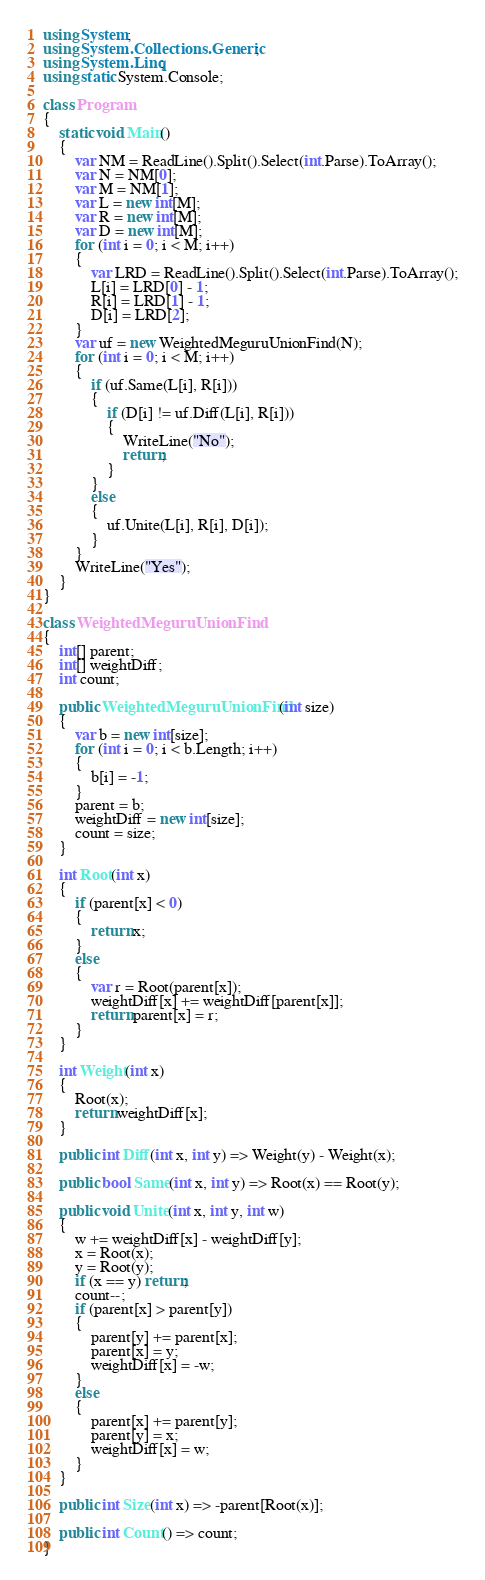<code> <loc_0><loc_0><loc_500><loc_500><_C#_>using System;
using System.Collections.Generic;
using System.Linq;
using static System.Console;

class Program
{
    static void Main()
    {
        var NM = ReadLine().Split().Select(int.Parse).ToArray();
        var N = NM[0];
        var M = NM[1];
        var L = new int[M];
        var R = new int[M];
        var D = new int[M];
        for (int i = 0; i < M; i++)
        {
            var LRD = ReadLine().Split().Select(int.Parse).ToArray();
            L[i] = LRD[0] - 1;
            R[i] = LRD[1] - 1;
            D[i] = LRD[2];
        }
        var uf = new WeightedMeguruUnionFind(N);
        for (int i = 0; i < M; i++)
        {
            if (uf.Same(L[i], R[i]))
            {
                if (D[i] != uf.Diff(L[i], R[i]))
                {
                    WriteLine("No");
                    return;
                }
            }
            else
            {
                uf.Unite(L[i], R[i], D[i]);
            }
        }
        WriteLine("Yes");
    }
}

class WeightedMeguruUnionFind
{
    int[] parent;
    int[] weightDiff;
    int count;

    public WeightedMeguruUnionFind(int size)
    {
        var b = new int[size];
        for (int i = 0; i < b.Length; i++)
        {
            b[i] = -1;
        }
        parent = b;
        weightDiff = new int[size];
        count = size;
    }

    int Root(int x)
    {
        if (parent[x] < 0)
        {
            return x;
        }
        else
        {
            var r = Root(parent[x]);
            weightDiff[x] += weightDiff[parent[x]];
            return parent[x] = r;
        }
    }

    int Weight(int x)
    {
        Root(x);
        return weightDiff[x];
    }

    public int Diff(int x, int y) => Weight(y) - Weight(x);

    public bool Same(int x, int y) => Root(x) == Root(y);

    public void Unite(int x, int y, int w)
    {
        w += weightDiff[x] - weightDiff[y];
        x = Root(x);
        y = Root(y);
        if (x == y) return;
        count--;
        if (parent[x] > parent[y])
        {
            parent[y] += parent[x];
            parent[x] = y;
            weightDiff[x] = -w;
        }
        else
        {
            parent[x] += parent[y];
            parent[y] = x;
            weightDiff[x] = w;
        }
    }

    public int Size(int x) => -parent[Root(x)];

    public int Count() => count;
}</code> 